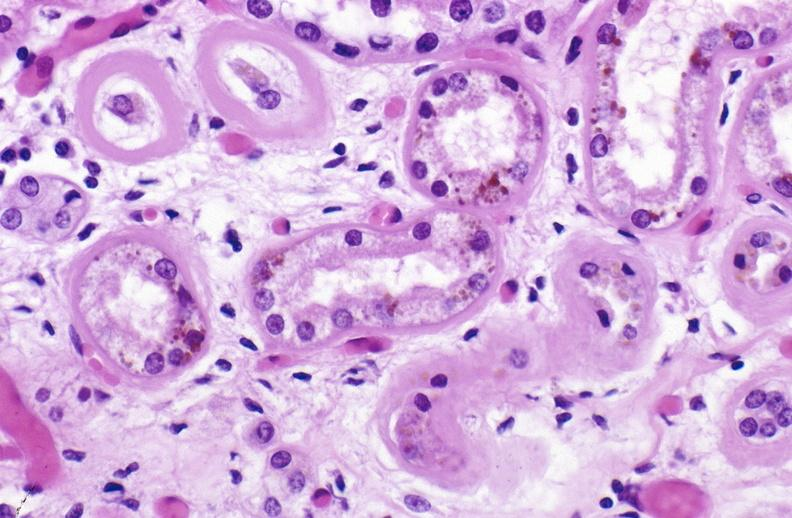does male reproductive show atn and bile pigment?
Answer the question using a single word or phrase. No 